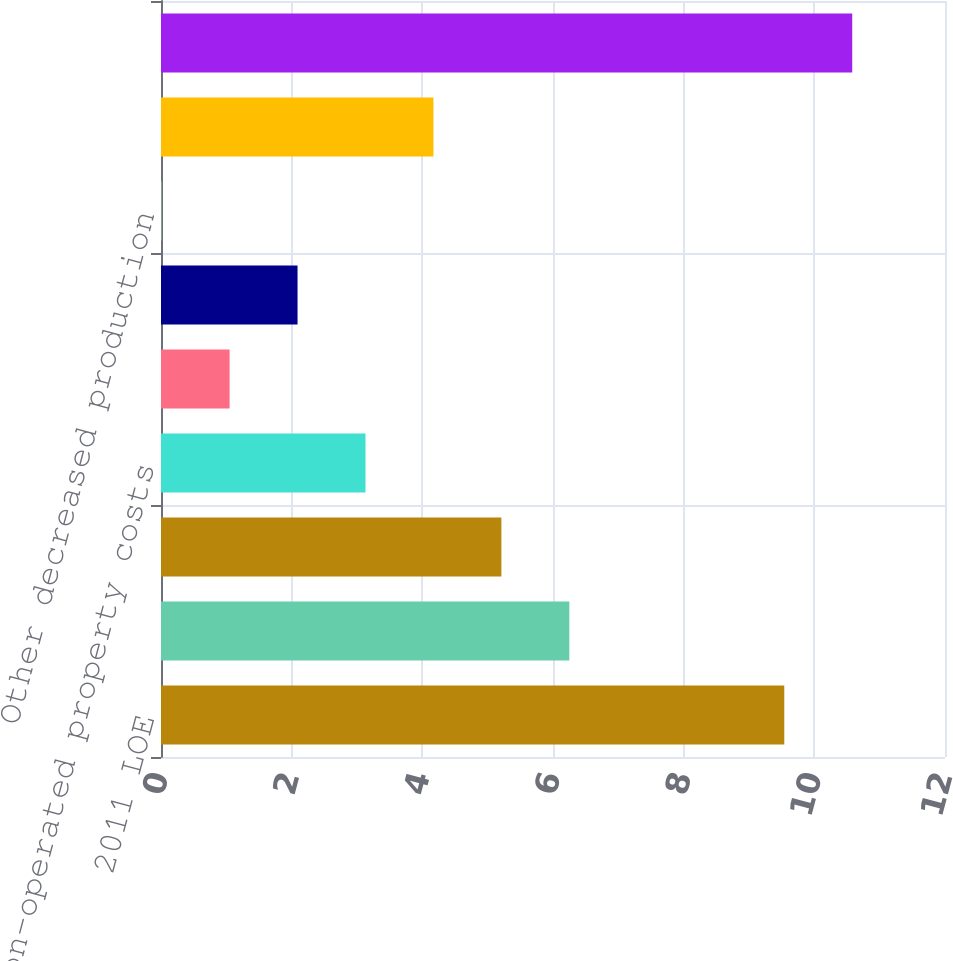<chart> <loc_0><loc_0><loc_500><loc_500><bar_chart><fcel>2011 LOE<fcel>Repairs and maintenance<fcel>Labor and pumper costs<fcel>Non-operated property costs<fcel>Workover costs<fcel>Other<fcel>Other decreased production<fcel>Acquisitions (1)<fcel>2012 LOE<nl><fcel>9.54<fcel>6.25<fcel>5.21<fcel>3.13<fcel>1.05<fcel>2.09<fcel>0.01<fcel>4.17<fcel>10.58<nl></chart> 